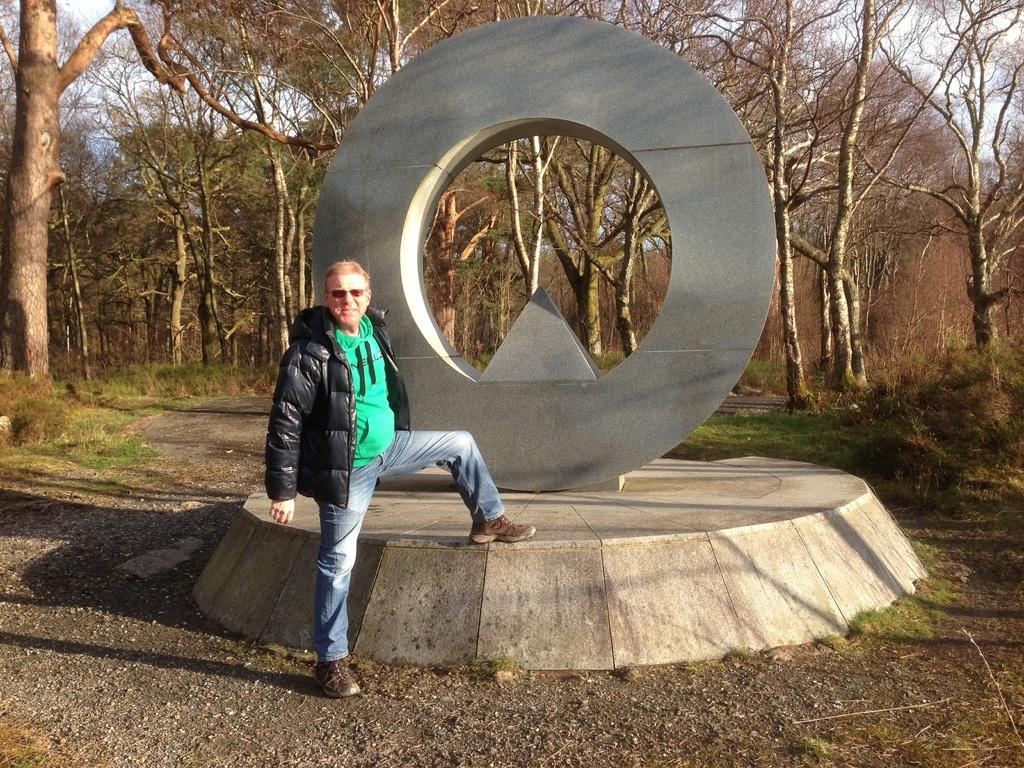What is the main subject of the image? There is a person in the image. What is the person wearing? The person is wearing a jacket and goggles. What is the person's posture in the image? The person is standing. What can be seen on a raised platform in the image? There is a sculpture on a platform in the image. What is visible in the background of the image? There is a road and trees in the background of the image. What type of circle can be seen on the person's jacket in the image? There is no circle visible on the person's jacket in the image. What is the person made of in the image? The person is a real person, not made of wax, as they are wearing a jacket and goggles. 